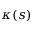Convert formula to latex. <formula><loc_0><loc_0><loc_500><loc_500>\kappa ( s )</formula> 